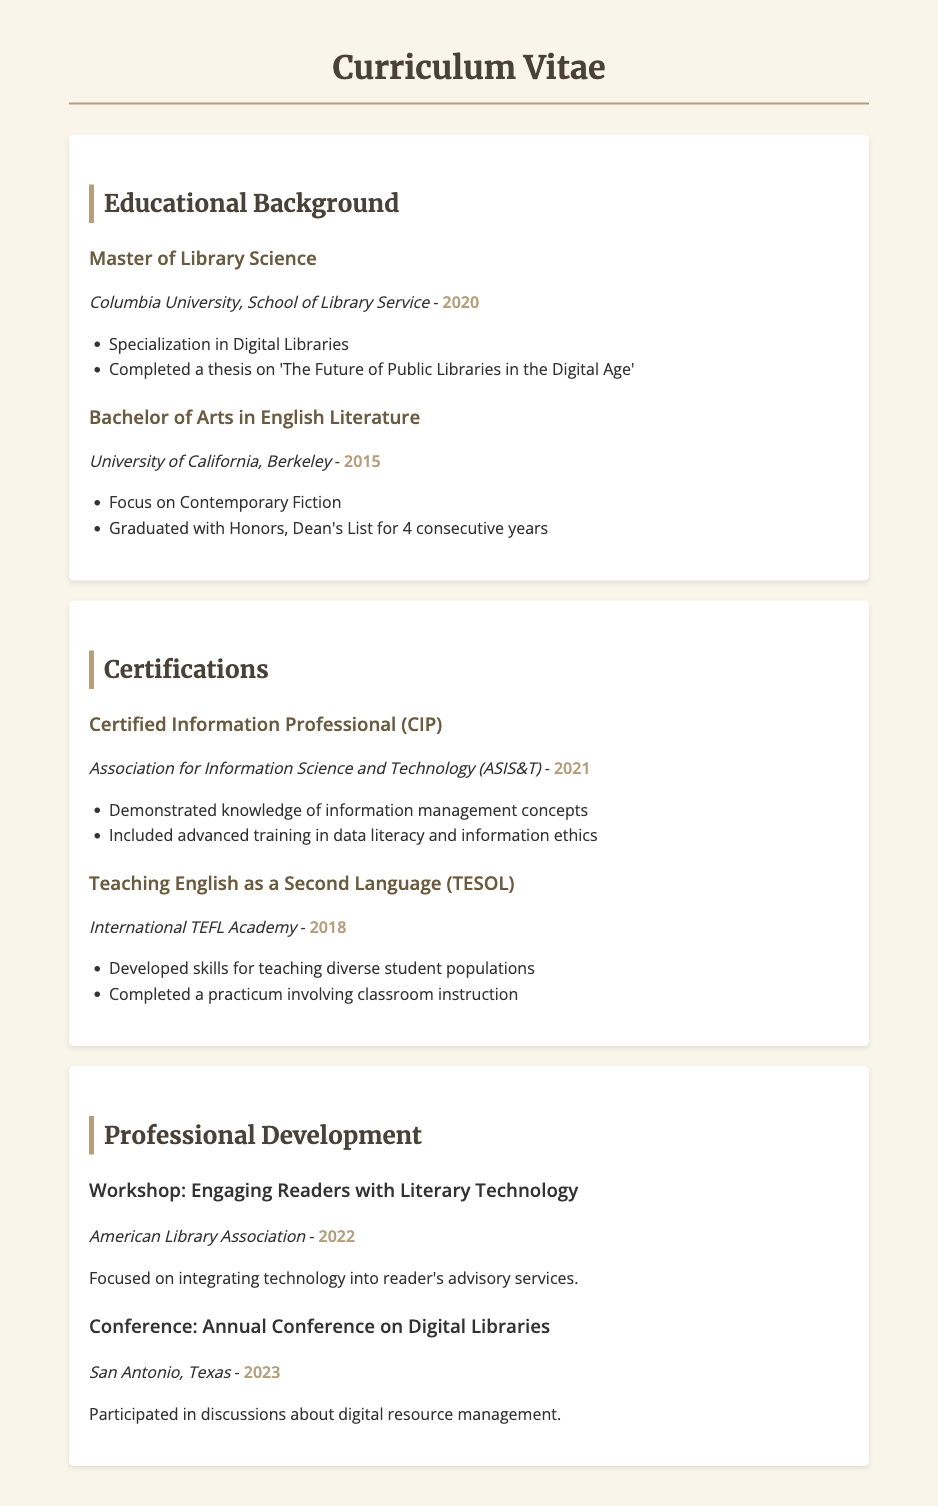What degree was earned in 2020? The document states that a Master of Library Science was earned in 2020.
Answer: Master of Library Science Which university awarded the Bachelor of Arts degree? According to the document, the Bachelor of Arts in English Literature was awarded by the University of California, Berkeley.
Answer: University of California, Berkeley What is the focus of the Master of Library Science specialization? The specialization mentioned in the document for the Master of Library Science is Digital Libraries.
Answer: Digital Libraries In which year was the Certified Information Professional certification obtained? The document lists the year for the Certified Information Professional certification as 2021.
Answer: 2021 What topic did the workshop in 2022 focus on? The document indicates that the workshop in 2022 focused on integrating technology into reader's advisory services.
Answer: Engaging Readers with Literary Technology What honor was received while completing the Bachelor’s degree? The document states that the individual graduated with honors and was on the Dean's List for 4 consecutive years.
Answer: Graduated with Honors, Dean's List What was the title of the thesis completed during the Master’s degree? The document mentions the thesis title as 'The Future of Public Libraries in the Digital Age'.
Answer: The Future of Public Libraries in the Digital Age Who organized the workshop attended in 2022? The document identifies the American Library Association as the organizer of the workshop in 2022.
Answer: American Library Association What does TESOL stand for? The document indicates that TESOL refers to Teaching English as a Second Language.
Answer: Teaching English as a Second Language 